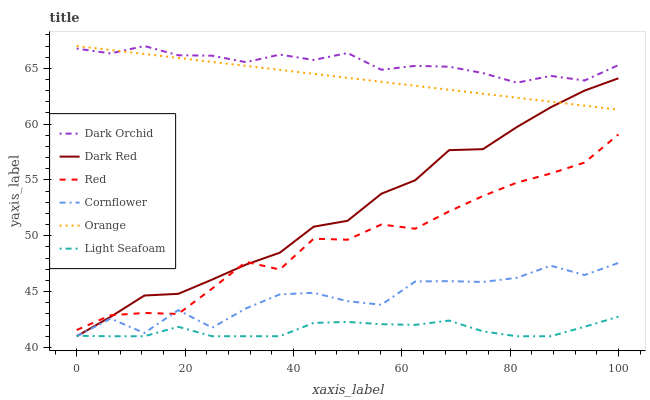Does Light Seafoam have the minimum area under the curve?
Answer yes or no. Yes. Does Dark Orchid have the maximum area under the curve?
Answer yes or no. Yes. Does Dark Red have the minimum area under the curve?
Answer yes or no. No. Does Dark Red have the maximum area under the curve?
Answer yes or no. No. Is Orange the smoothest?
Answer yes or no. Yes. Is Cornflower the roughest?
Answer yes or no. Yes. Is Dark Red the smoothest?
Answer yes or no. No. Is Dark Red the roughest?
Answer yes or no. No. Does Dark Orchid have the lowest value?
Answer yes or no. No. Does Dark Red have the highest value?
Answer yes or no. No. Is Cornflower less than Dark Orchid?
Answer yes or no. Yes. Is Dark Orchid greater than Light Seafoam?
Answer yes or no. Yes. Does Cornflower intersect Dark Orchid?
Answer yes or no. No. 